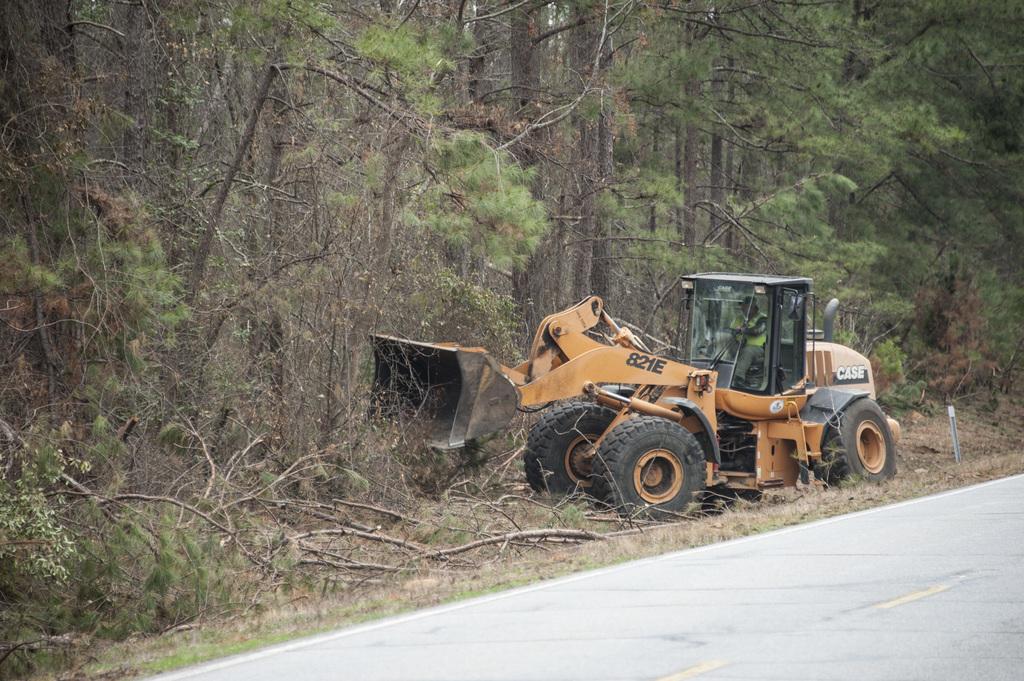What company is mentioned in this tractor?
Offer a terse response. Case. 